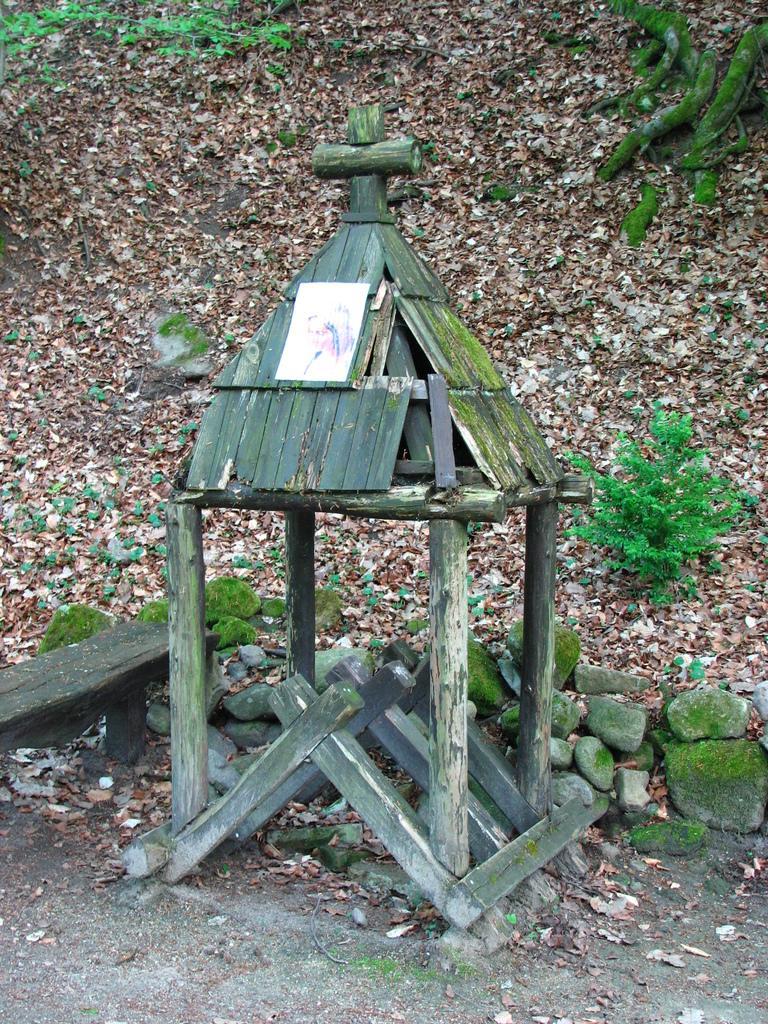Describe this image in one or two sentences. In the image we can see a small hut, made up of wood. There are the stones, dry leaves, plants and a grass. 